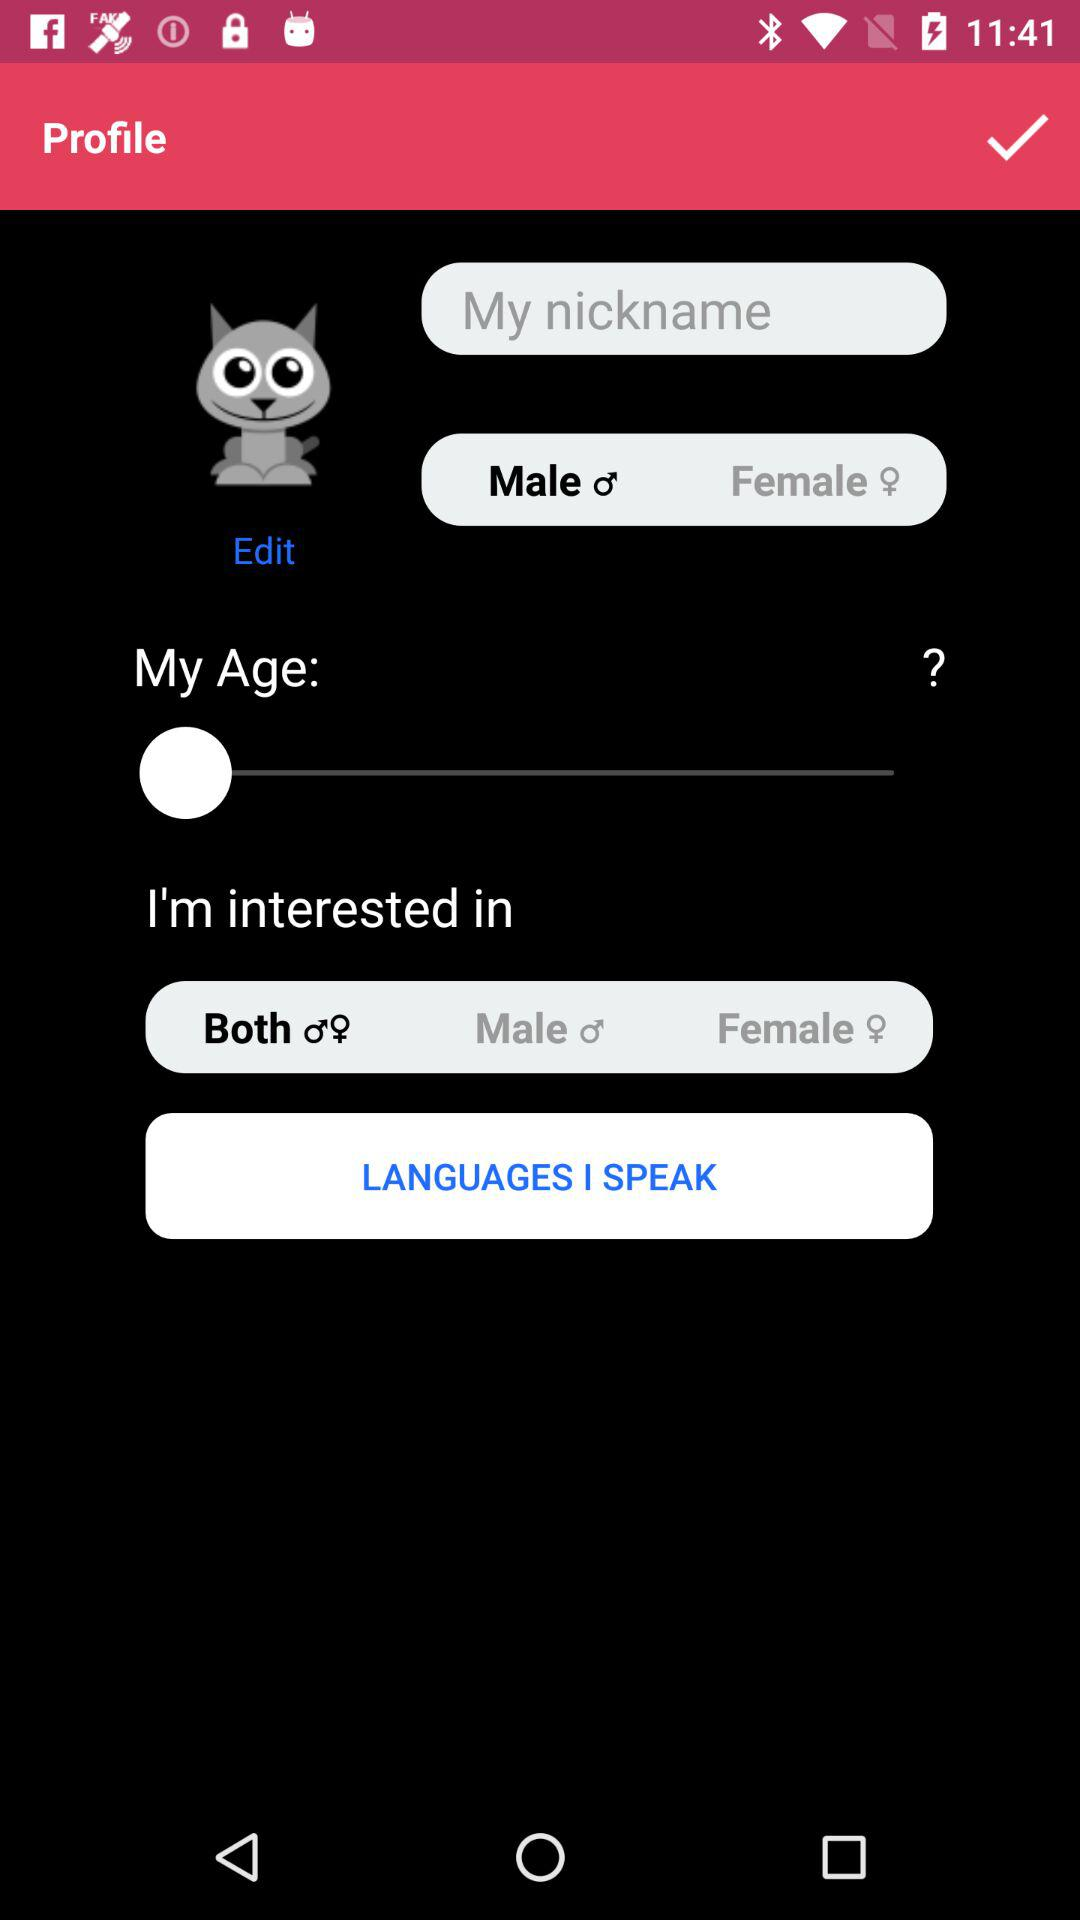What is the type of selected interest? The selected interest is "Both". 